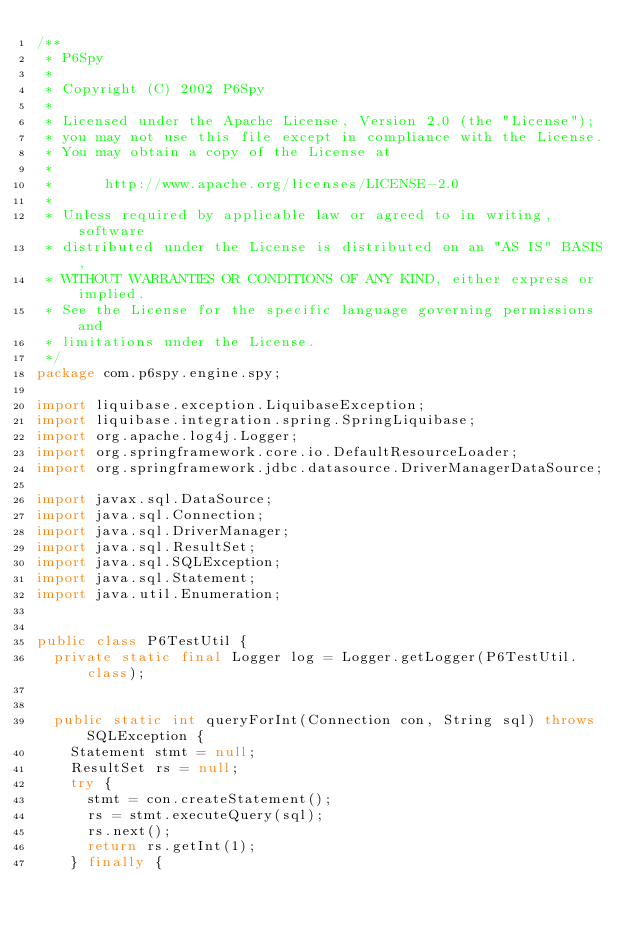Convert code to text. <code><loc_0><loc_0><loc_500><loc_500><_Java_>/**
 * P6Spy
 *
 * Copyright (C) 2002 P6Spy
 *
 * Licensed under the Apache License, Version 2.0 (the "License");
 * you may not use this file except in compliance with the License.
 * You may obtain a copy of the License at
 *
 *      http://www.apache.org/licenses/LICENSE-2.0
 *
 * Unless required by applicable law or agreed to in writing, software
 * distributed under the License is distributed on an "AS IS" BASIS,
 * WITHOUT WARRANTIES OR CONDITIONS OF ANY KIND, either express or implied.
 * See the License for the specific language governing permissions and
 * limitations under the License.
 */
package com.p6spy.engine.spy;

import liquibase.exception.LiquibaseException;
import liquibase.integration.spring.SpringLiquibase;
import org.apache.log4j.Logger;
import org.springframework.core.io.DefaultResourceLoader;
import org.springframework.jdbc.datasource.DriverManagerDataSource;

import javax.sql.DataSource;
import java.sql.Connection;
import java.sql.DriverManager;
import java.sql.ResultSet;
import java.sql.SQLException;
import java.sql.Statement;
import java.util.Enumeration;


public class P6TestUtil {
  private static final Logger log = Logger.getLogger(P6TestUtil.class);

  
  public static int queryForInt(Connection con, String sql) throws SQLException {
    Statement stmt = null;
    ResultSet rs = null;
    try {
      stmt = con.createStatement();
      rs = stmt.executeQuery(sql);
      rs.next();
      return rs.getInt(1);
    } finally {</code> 